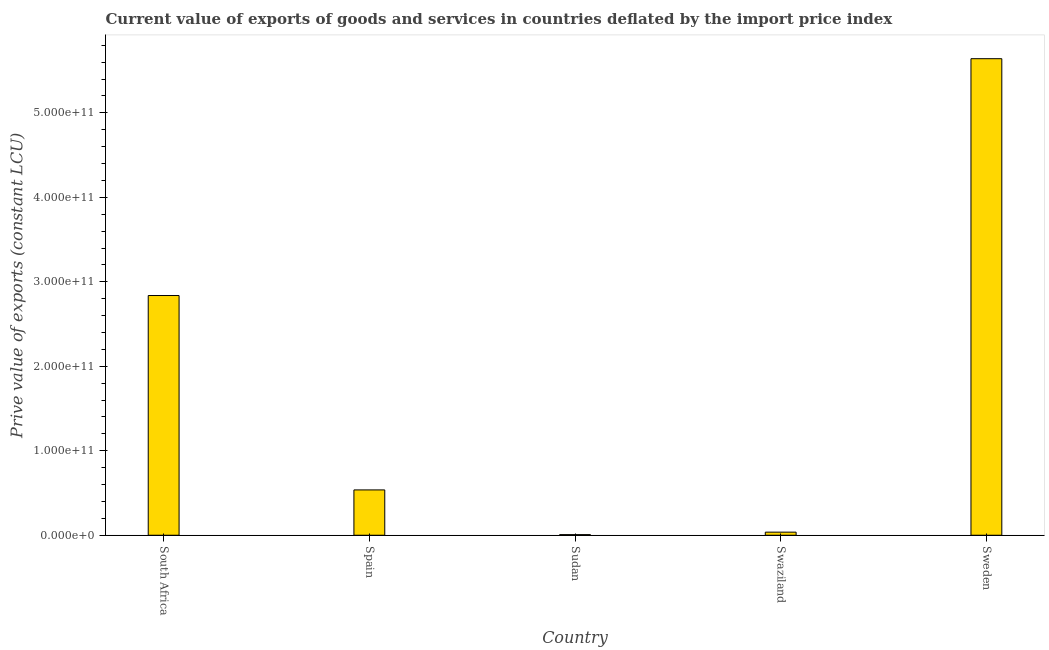What is the title of the graph?
Provide a short and direct response. Current value of exports of goods and services in countries deflated by the import price index. What is the label or title of the Y-axis?
Give a very brief answer. Prive value of exports (constant LCU). What is the price value of exports in Spain?
Ensure brevity in your answer.  5.36e+1. Across all countries, what is the maximum price value of exports?
Your answer should be very brief. 5.64e+11. Across all countries, what is the minimum price value of exports?
Offer a very short reply. 7.18e+08. In which country was the price value of exports minimum?
Offer a terse response. Sudan. What is the sum of the price value of exports?
Provide a succinct answer. 9.06e+11. What is the difference between the price value of exports in South Africa and Swaziland?
Your answer should be very brief. 2.80e+11. What is the average price value of exports per country?
Your response must be concise. 1.81e+11. What is the median price value of exports?
Your answer should be compact. 5.36e+1. What is the ratio of the price value of exports in South Africa to that in Sudan?
Your response must be concise. 395.36. What is the difference between the highest and the second highest price value of exports?
Provide a succinct answer. 2.80e+11. What is the difference between the highest and the lowest price value of exports?
Your answer should be compact. 5.63e+11. What is the difference between two consecutive major ticks on the Y-axis?
Provide a succinct answer. 1.00e+11. What is the Prive value of exports (constant LCU) in South Africa?
Provide a short and direct response. 2.84e+11. What is the Prive value of exports (constant LCU) of Spain?
Give a very brief answer. 5.36e+1. What is the Prive value of exports (constant LCU) in Sudan?
Keep it short and to the point. 7.18e+08. What is the Prive value of exports (constant LCU) in Swaziland?
Offer a terse response. 3.65e+09. What is the Prive value of exports (constant LCU) in Sweden?
Provide a short and direct response. 5.64e+11. What is the difference between the Prive value of exports (constant LCU) in South Africa and Spain?
Make the answer very short. 2.30e+11. What is the difference between the Prive value of exports (constant LCU) in South Africa and Sudan?
Give a very brief answer. 2.83e+11. What is the difference between the Prive value of exports (constant LCU) in South Africa and Swaziland?
Your answer should be compact. 2.80e+11. What is the difference between the Prive value of exports (constant LCU) in South Africa and Sweden?
Keep it short and to the point. -2.80e+11. What is the difference between the Prive value of exports (constant LCU) in Spain and Sudan?
Provide a short and direct response. 5.29e+1. What is the difference between the Prive value of exports (constant LCU) in Spain and Swaziland?
Your response must be concise. 5.00e+1. What is the difference between the Prive value of exports (constant LCU) in Spain and Sweden?
Provide a succinct answer. -5.10e+11. What is the difference between the Prive value of exports (constant LCU) in Sudan and Swaziland?
Provide a short and direct response. -2.93e+09. What is the difference between the Prive value of exports (constant LCU) in Sudan and Sweden?
Offer a very short reply. -5.63e+11. What is the difference between the Prive value of exports (constant LCU) in Swaziland and Sweden?
Ensure brevity in your answer.  -5.60e+11. What is the ratio of the Prive value of exports (constant LCU) in South Africa to that in Spain?
Your answer should be very brief. 5.29. What is the ratio of the Prive value of exports (constant LCU) in South Africa to that in Sudan?
Make the answer very short. 395.36. What is the ratio of the Prive value of exports (constant LCU) in South Africa to that in Swaziland?
Offer a very short reply. 77.81. What is the ratio of the Prive value of exports (constant LCU) in South Africa to that in Sweden?
Make the answer very short. 0.5. What is the ratio of the Prive value of exports (constant LCU) in Spain to that in Sudan?
Your answer should be very brief. 74.74. What is the ratio of the Prive value of exports (constant LCU) in Spain to that in Swaziland?
Your response must be concise. 14.71. What is the ratio of the Prive value of exports (constant LCU) in Spain to that in Sweden?
Make the answer very short. 0.1. What is the ratio of the Prive value of exports (constant LCU) in Sudan to that in Swaziland?
Your response must be concise. 0.2. What is the ratio of the Prive value of exports (constant LCU) in Sudan to that in Sweden?
Your answer should be compact. 0. What is the ratio of the Prive value of exports (constant LCU) in Swaziland to that in Sweden?
Ensure brevity in your answer.  0.01. 